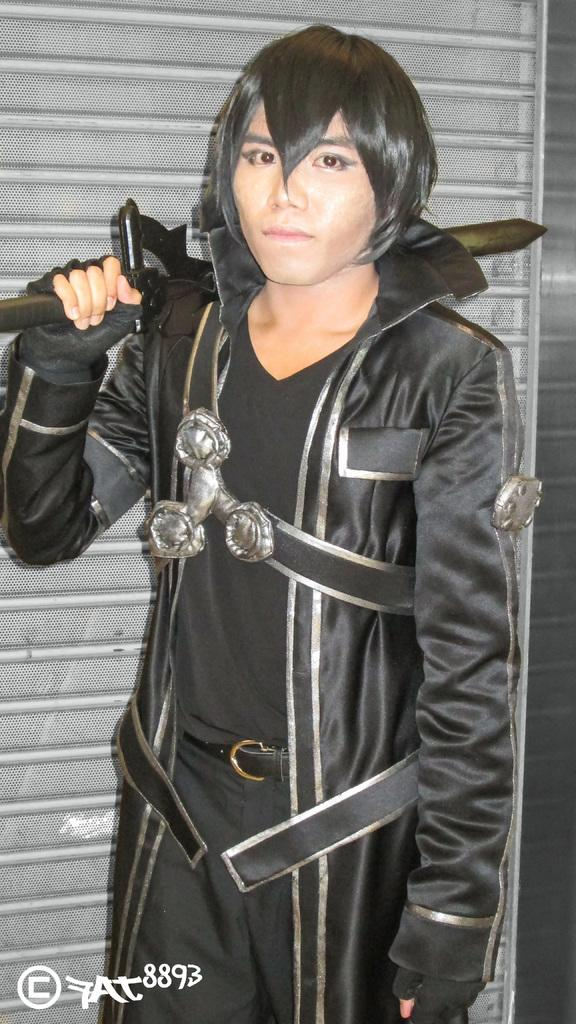What is the main subject of the image? There is a person in the image. What is the person wearing? The person is wearing a black dress. What object is the person holding? The person is holding a sword. What type of plane can be seen in the background of the image? There is no plane visible in the image; it only features a person holding a sword. What type of plantation is present in the image? There is no plantation present in the image; it only features a person holding a sword. 